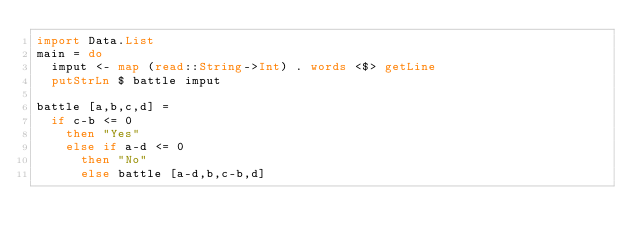<code> <loc_0><loc_0><loc_500><loc_500><_Haskell_>import Data.List
main = do
  imput <- map (read::String->Int) . words <$> getLine
  putStrLn $ battle imput

battle [a,b,c,d] =
  if c-b <= 0
    then "Yes"
    else if a-d <= 0
      then "No"
      else battle [a-d,b,c-b,d]</code> 